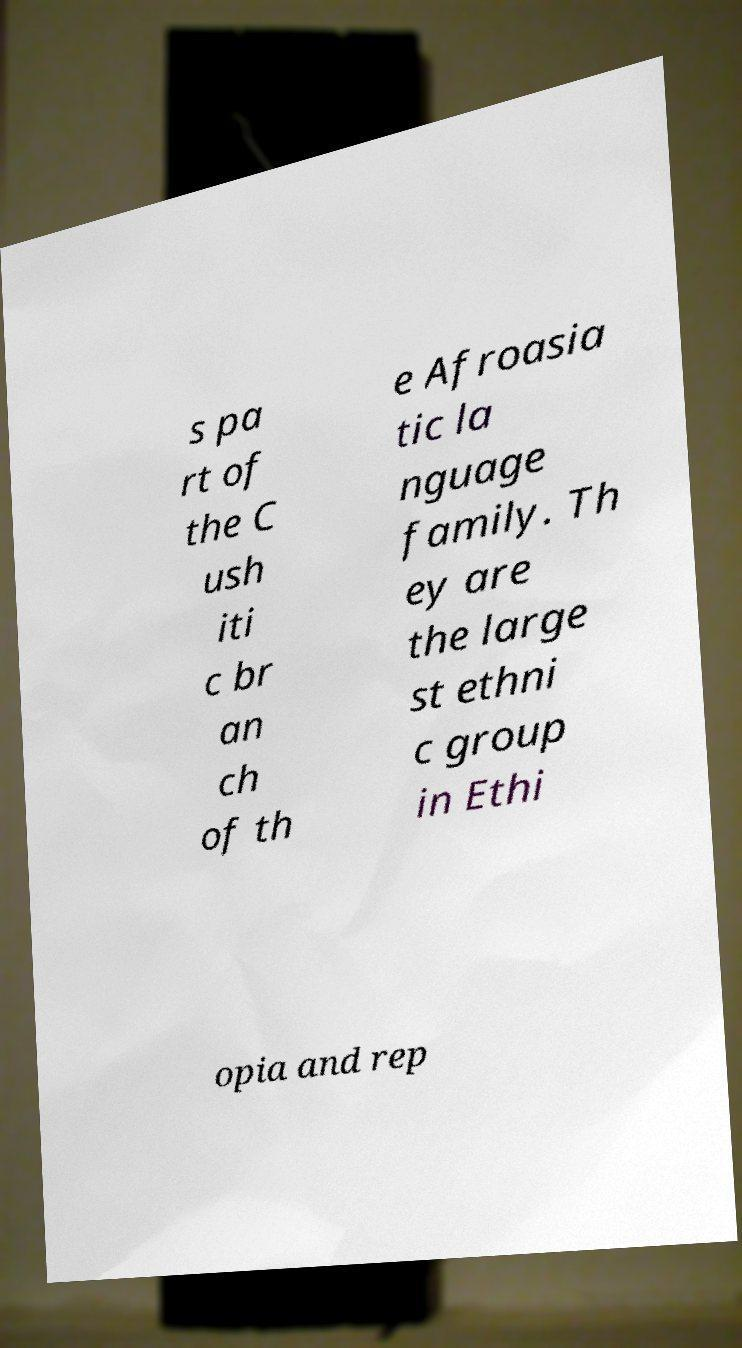Please read and relay the text visible in this image. What does it say? s pa rt of the C ush iti c br an ch of th e Afroasia tic la nguage family. Th ey are the large st ethni c group in Ethi opia and rep 